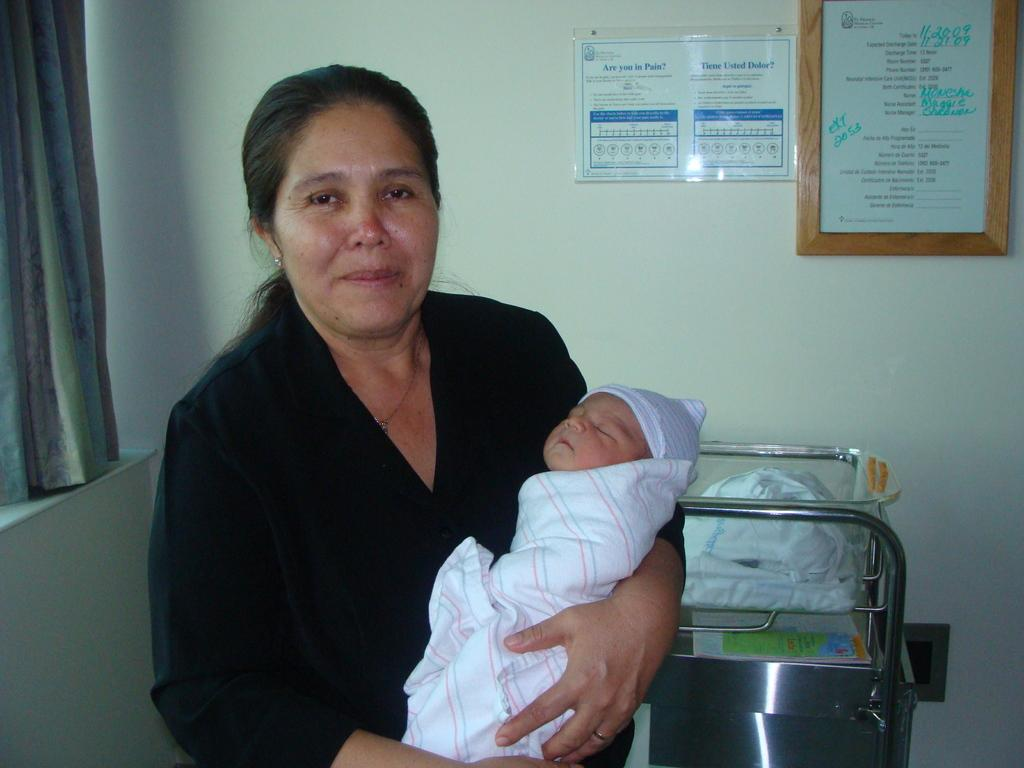Provide a one-sentence caption for the provided image. A woman holding a baby in a room with a sign on the wall that says "Are you in pain?". 